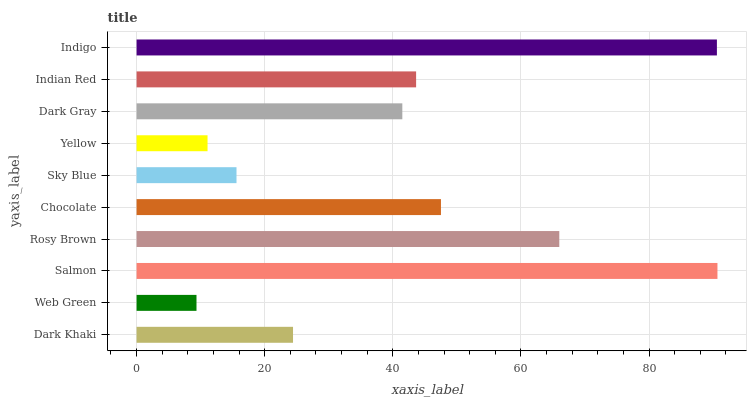Is Web Green the minimum?
Answer yes or no. Yes. Is Salmon the maximum?
Answer yes or no. Yes. Is Salmon the minimum?
Answer yes or no. No. Is Web Green the maximum?
Answer yes or no. No. Is Salmon greater than Web Green?
Answer yes or no. Yes. Is Web Green less than Salmon?
Answer yes or no. Yes. Is Web Green greater than Salmon?
Answer yes or no. No. Is Salmon less than Web Green?
Answer yes or no. No. Is Indian Red the high median?
Answer yes or no. Yes. Is Dark Gray the low median?
Answer yes or no. Yes. Is Sky Blue the high median?
Answer yes or no. No. Is Dark Khaki the low median?
Answer yes or no. No. 